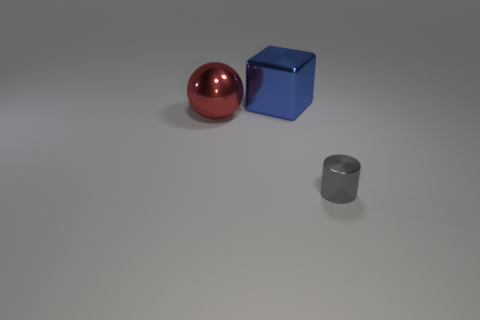Add 3 small gray metallic objects. How many objects exist? 6 Subtract all spheres. How many objects are left? 2 Add 1 tiny cylinders. How many tiny cylinders are left? 2 Add 2 red balls. How many red balls exist? 3 Subtract 0 yellow cylinders. How many objects are left? 3 Subtract all cyan metallic blocks. Subtract all large blue things. How many objects are left? 2 